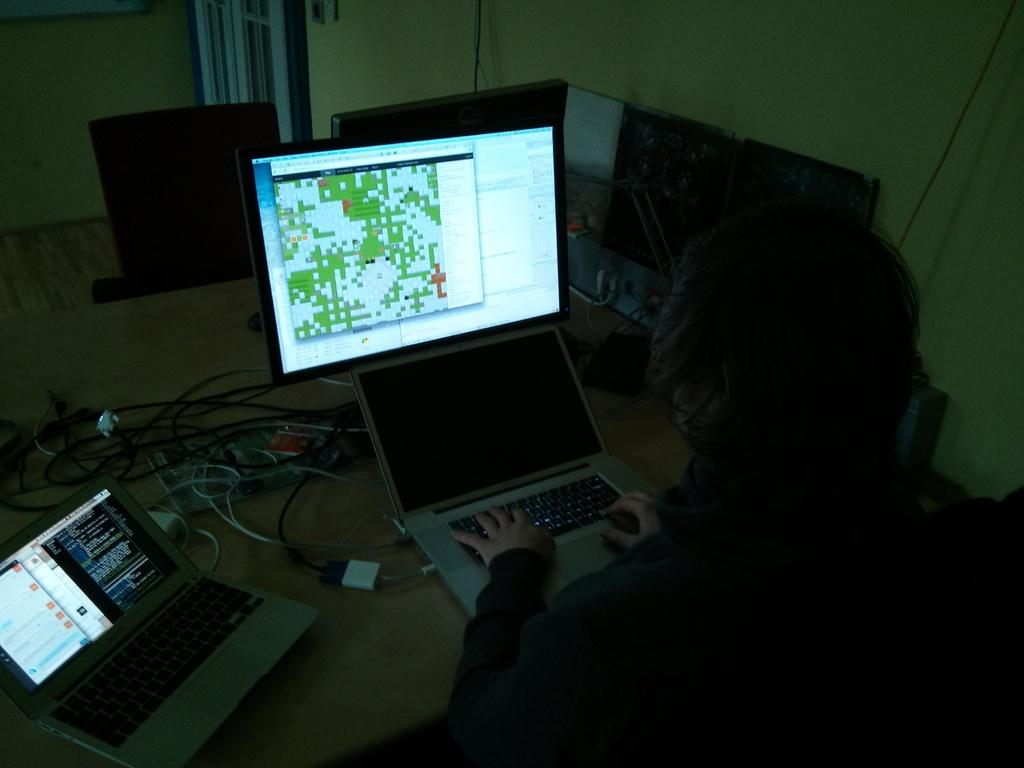What is the person in the image doing? The person is sitting on a chair in the image. What object is in front of the person? There is a laptop in front of the person. What can be seen in the background of the image? There is a wall and a window in the background of the image. What type of button is being pressed by the person on the chair in the image? There is no button being pressed by the person in the image; they are simply sitting on a chair with a laptop in front of them. 